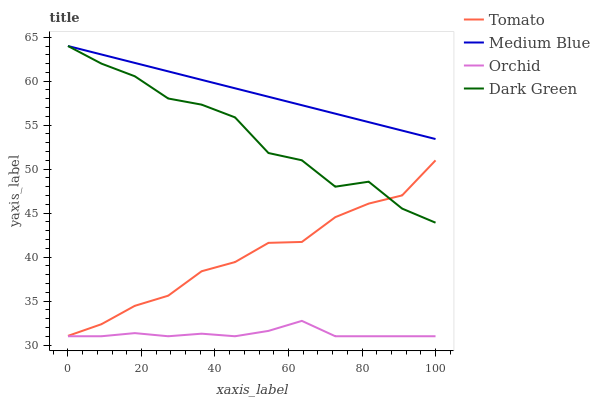Does Orchid have the minimum area under the curve?
Answer yes or no. Yes. Does Medium Blue have the maximum area under the curve?
Answer yes or no. Yes. Does Dark Green have the minimum area under the curve?
Answer yes or no. No. Does Dark Green have the maximum area under the curve?
Answer yes or no. No. Is Medium Blue the smoothest?
Answer yes or no. Yes. Is Dark Green the roughest?
Answer yes or no. Yes. Is Dark Green the smoothest?
Answer yes or no. No. Is Medium Blue the roughest?
Answer yes or no. No. Does Dark Green have the lowest value?
Answer yes or no. No. Does Medium Blue have the highest value?
Answer yes or no. Yes. Does Orchid have the highest value?
Answer yes or no. No. Is Orchid less than Dark Green?
Answer yes or no. Yes. Is Dark Green greater than Orchid?
Answer yes or no. Yes. Does Dark Green intersect Tomato?
Answer yes or no. Yes. Is Dark Green less than Tomato?
Answer yes or no. No. Is Dark Green greater than Tomato?
Answer yes or no. No. Does Orchid intersect Dark Green?
Answer yes or no. No. 